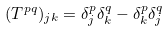Convert formula to latex. <formula><loc_0><loc_0><loc_500><loc_500>( T ^ { p q } ) _ { j k } = \delta ^ { p } _ { j } \delta ^ { q } _ { k } - \delta ^ { p } _ { k } \delta ^ { q } _ { j }</formula> 